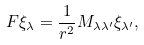Convert formula to latex. <formula><loc_0><loc_0><loc_500><loc_500>F \xi _ { \lambda } = \frac { 1 } { r ^ { 2 } } M _ { \lambda \lambda ^ { \prime } } \xi _ { \lambda ^ { \prime } } ,</formula> 